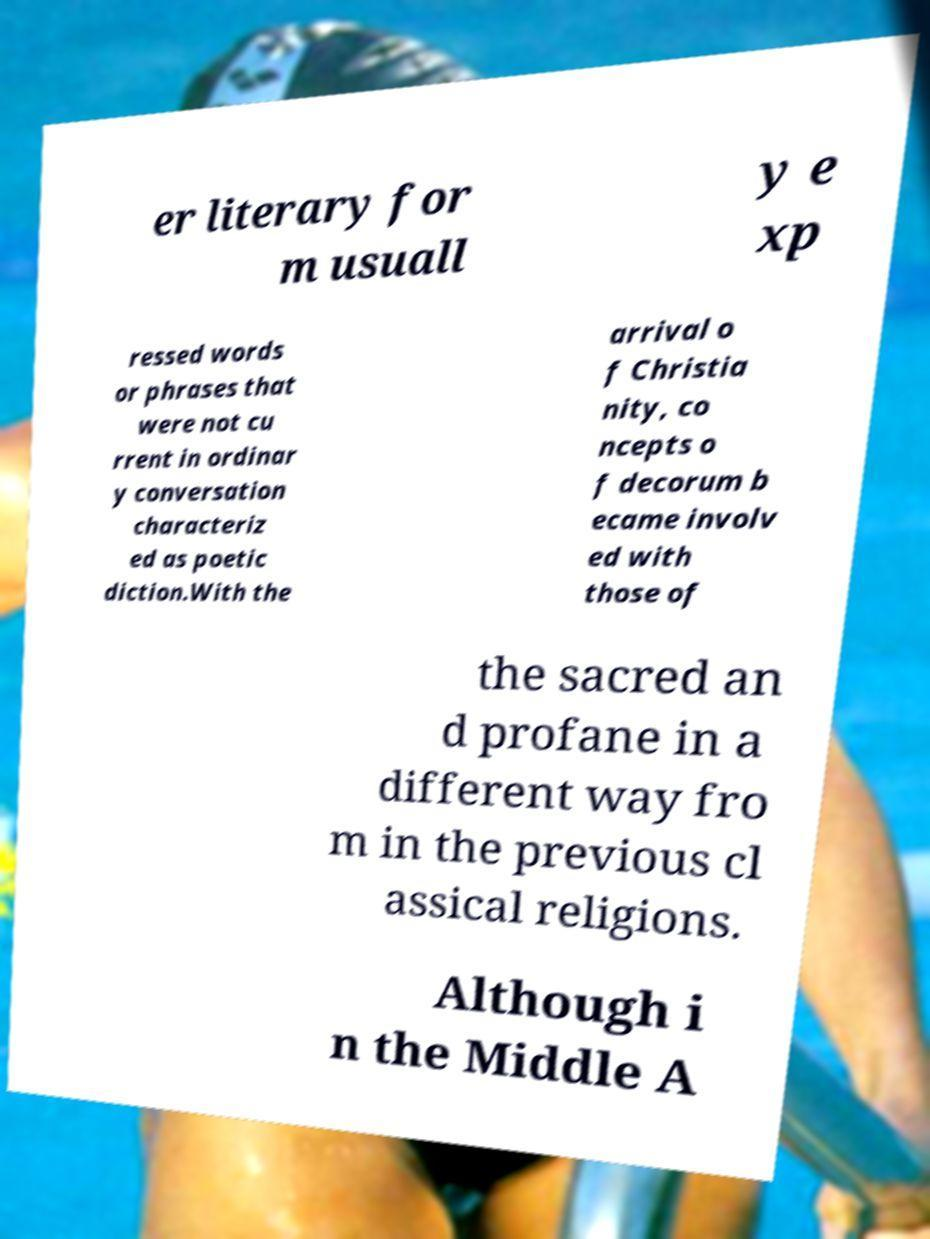Can you accurately transcribe the text from the provided image for me? er literary for m usuall y e xp ressed words or phrases that were not cu rrent in ordinar y conversation characteriz ed as poetic diction.With the arrival o f Christia nity, co ncepts o f decorum b ecame involv ed with those of the sacred an d profane in a different way fro m in the previous cl assical religions. Although i n the Middle A 